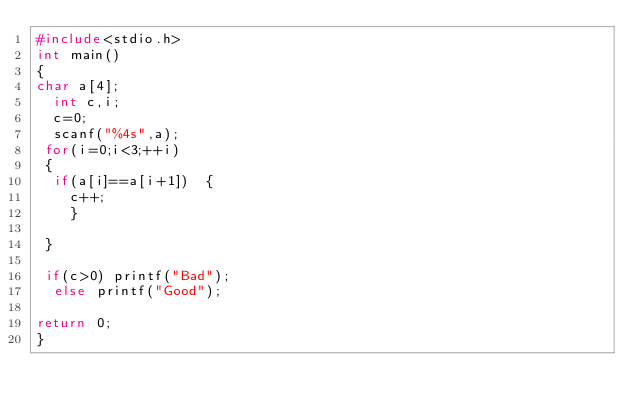<code> <loc_0><loc_0><loc_500><loc_500><_C_>#include<stdio.h>
int main()
{
char a[4];
  int c,i;
  c=0;
  scanf("%4s",a);
 for(i=0;i<3;++i)
 {
  if(a[i]==a[i+1])  {
    c++;
    }

 }
  
 if(c>0) printf("Bad");
  else printf("Good");
  
return 0;
}</code> 